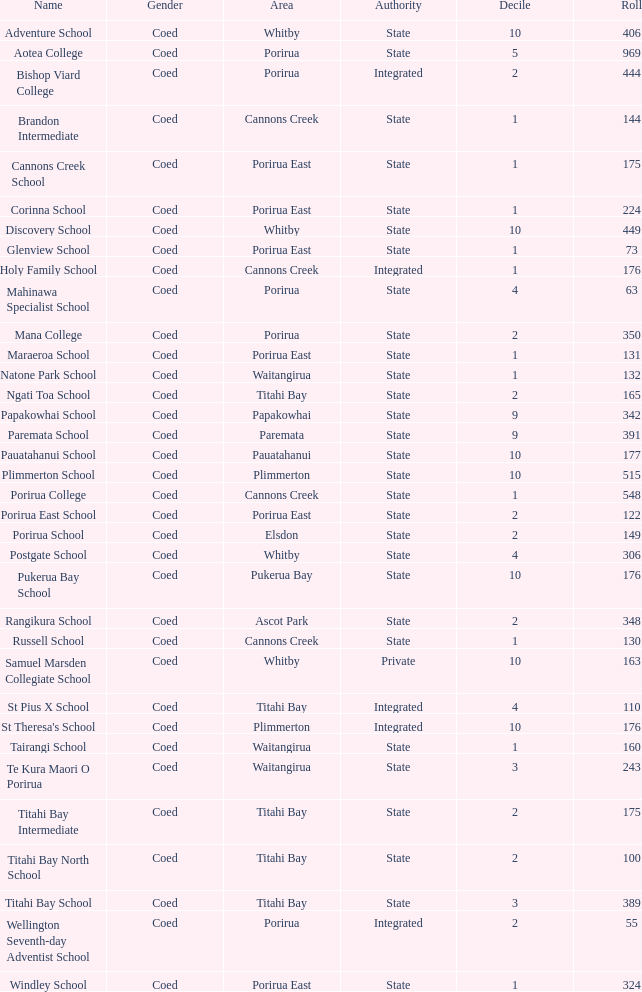What is the enrollment size of bishop viard college (an integrated college) with a decile higher than 1? 1.0. 